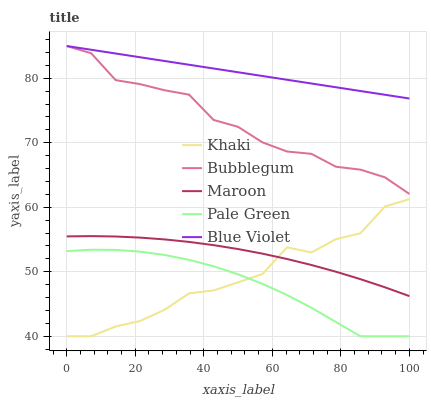Does Pale Green have the minimum area under the curve?
Answer yes or no. Yes. Does Blue Violet have the maximum area under the curve?
Answer yes or no. Yes. Does Khaki have the minimum area under the curve?
Answer yes or no. No. Does Khaki have the maximum area under the curve?
Answer yes or no. No. Is Blue Violet the smoothest?
Answer yes or no. Yes. Is Khaki the roughest?
Answer yes or no. Yes. Is Pale Green the smoothest?
Answer yes or no. No. Is Pale Green the roughest?
Answer yes or no. No. Does Pale Green have the lowest value?
Answer yes or no. Yes. Does Maroon have the lowest value?
Answer yes or no. No. Does Bubblegum have the highest value?
Answer yes or no. Yes. Does Khaki have the highest value?
Answer yes or no. No. Is Pale Green less than Maroon?
Answer yes or no. Yes. Is Blue Violet greater than Pale Green?
Answer yes or no. Yes. Does Khaki intersect Maroon?
Answer yes or no. Yes. Is Khaki less than Maroon?
Answer yes or no. No. Is Khaki greater than Maroon?
Answer yes or no. No. Does Pale Green intersect Maroon?
Answer yes or no. No. 